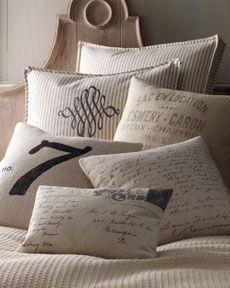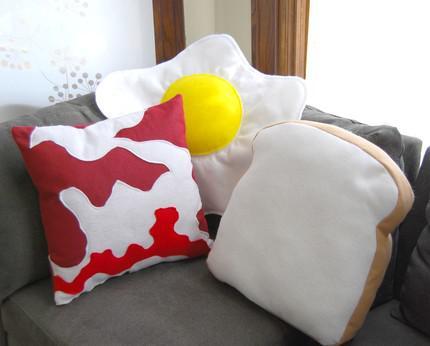The first image is the image on the left, the second image is the image on the right. Examine the images to the left and right. Is the description "An image includes at least one pillow shaped like a slice of bread." accurate? Answer yes or no. Yes. 